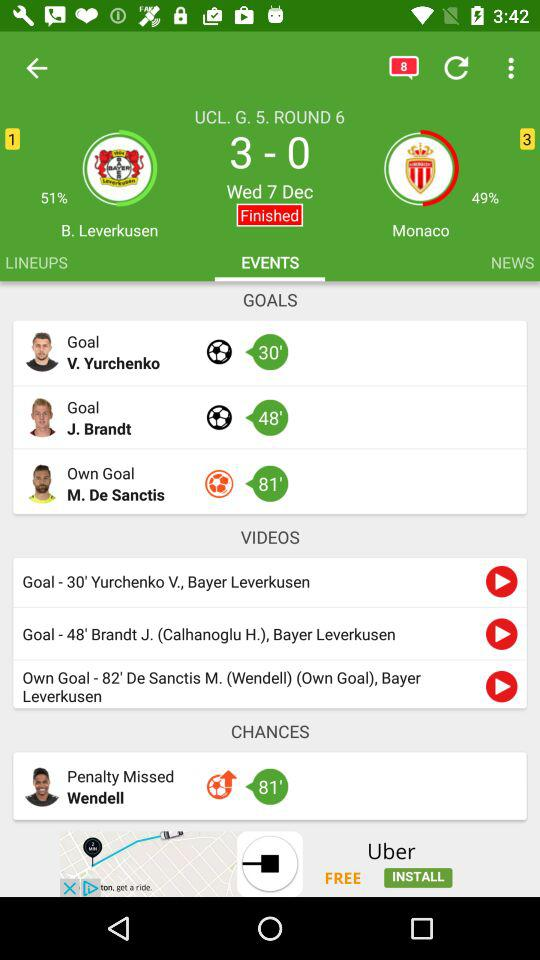How many more minutes did the first goal happen after the second goal?
Answer the question using a single word or phrase. 18 